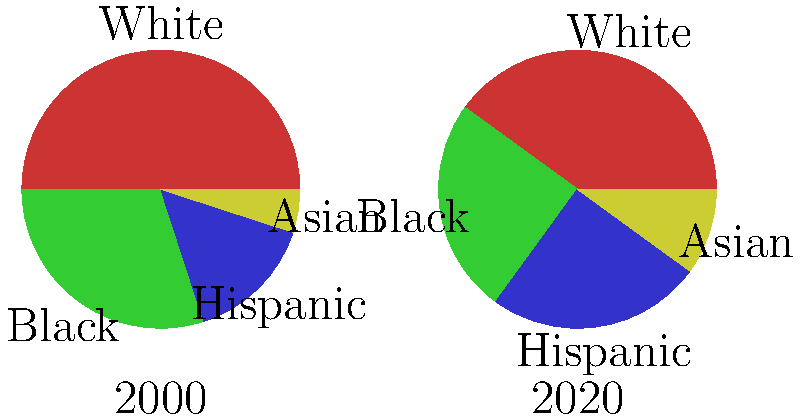As an author exploring racial demographics, analyze the changes in the city's ethnic composition from 2000 to 2020. Which group experienced the most significant percentage point increase, and how might this shift impact social dynamics and cultural narratives in your writing? To answer this question, we need to compare the percentage changes for each ethnic group from 2000 to 2020:

1. White population:
   2000: 50%, 2020: 40%
   Change: 50% - 40% = -10 percentage points

2. Black population:
   2000: 30%, 2020: 25%
   Change: 25% - 30% = -5 percentage points

3. Hispanic population:
   2000: 15%, 2020: 25%
   Change: 25% - 15% = +10 percentage points

4. Asian population:
   2000: 5%, 2020: 10%
   Change: 10% - 5% = +5 percentage points

The Hispanic population experienced the most significant percentage point increase at 10 points.

This shift could impact social dynamics and cultural narratives in several ways:
1. Increased visibility and representation of Hispanic culture
2. Potential changes in local politics and policy priorities
3. Greater demand for bilingual services and education
4. Possible tensions or opportunities for cross-cultural exchange
5. Economic shifts reflecting changing consumer demographics

As an author, this demographic change provides rich material for exploring themes of cultural identity, integration, and social change in an increasingly diverse urban landscape.
Answer: Hispanic population (+10 percentage points) 